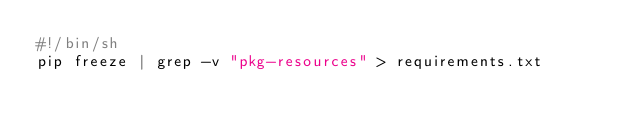<code> <loc_0><loc_0><loc_500><loc_500><_Bash_>#!/bin/sh
pip freeze | grep -v "pkg-resources" > requirements.txt
</code> 